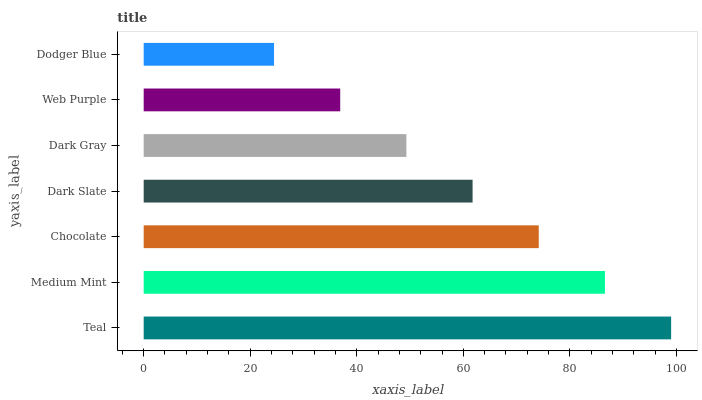Is Dodger Blue the minimum?
Answer yes or no. Yes. Is Teal the maximum?
Answer yes or no. Yes. Is Medium Mint the minimum?
Answer yes or no. No. Is Medium Mint the maximum?
Answer yes or no. No. Is Teal greater than Medium Mint?
Answer yes or no. Yes. Is Medium Mint less than Teal?
Answer yes or no. Yes. Is Medium Mint greater than Teal?
Answer yes or no. No. Is Teal less than Medium Mint?
Answer yes or no. No. Is Dark Slate the high median?
Answer yes or no. Yes. Is Dark Slate the low median?
Answer yes or no. Yes. Is Teal the high median?
Answer yes or no. No. Is Chocolate the low median?
Answer yes or no. No. 